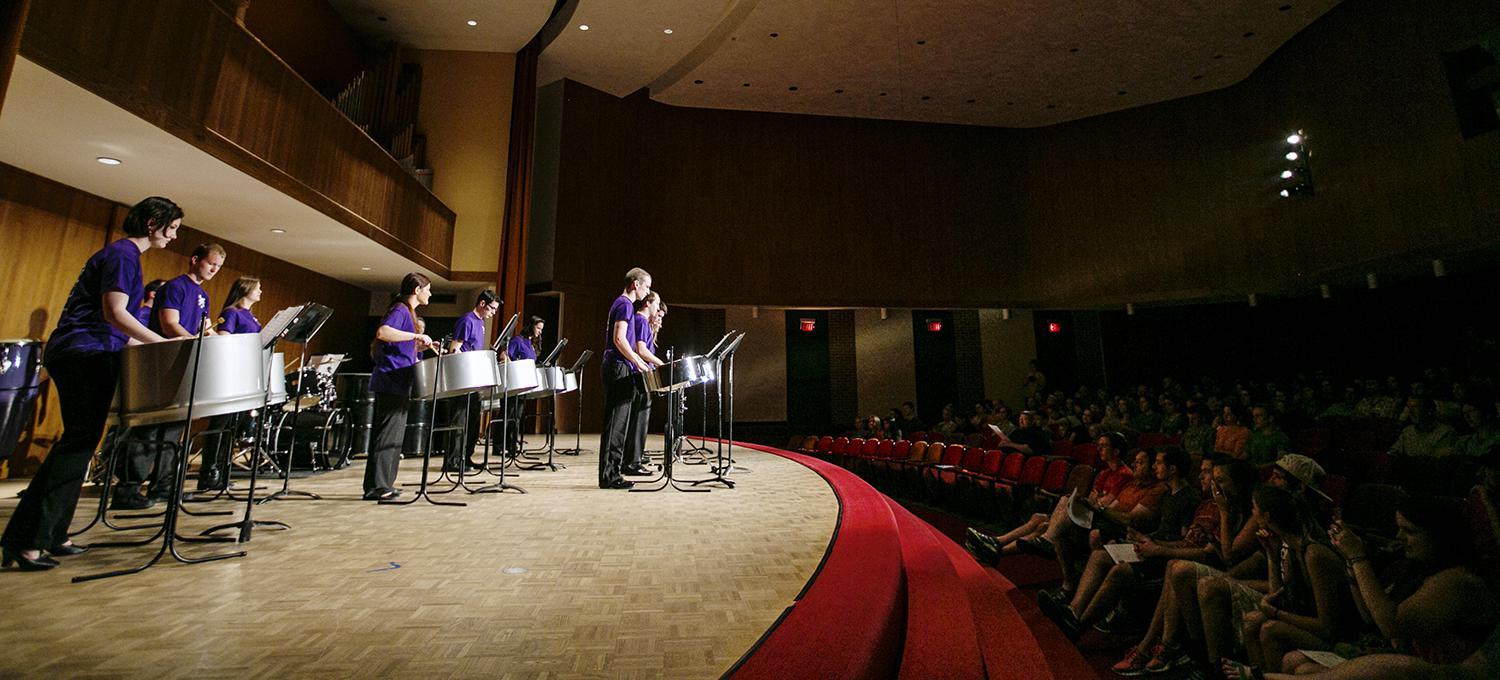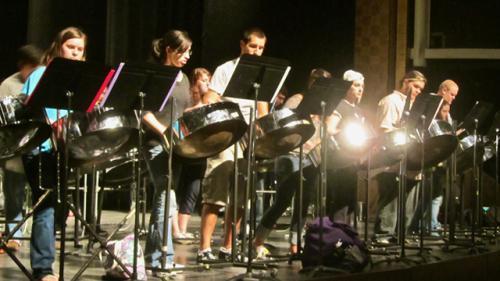The first image is the image on the left, the second image is the image on the right. Examine the images to the left and right. Is the description "All of the drummers in the image on the left are wearing purple shirts." accurate? Answer yes or no. Yes. The first image is the image on the left, the second image is the image on the right. Analyze the images presented: Is the assertion "The left image shows a group of musicians in black pants and violet-blue short-sleeved shirts standing in front of cylindrical drums." valid? Answer yes or no. Yes. 